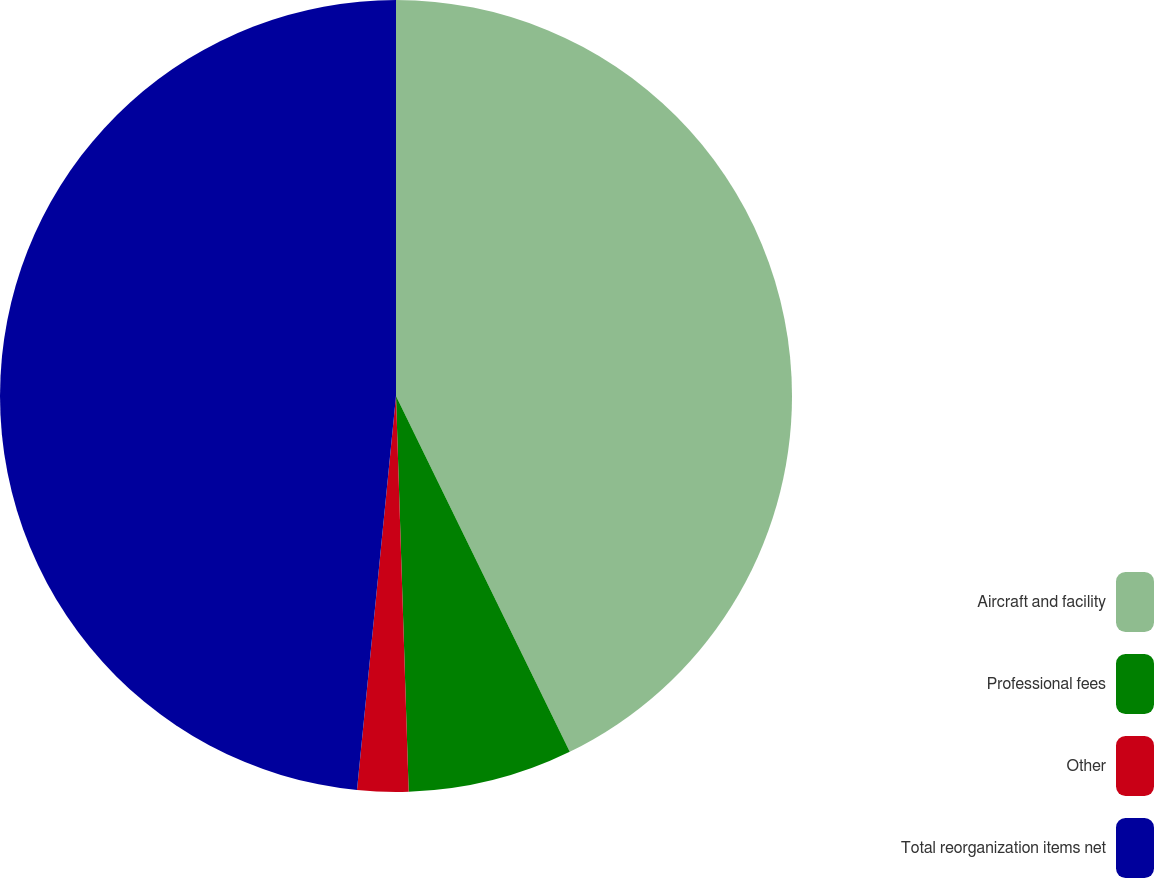Convert chart to OTSL. <chart><loc_0><loc_0><loc_500><loc_500><pie_chart><fcel>Aircraft and facility<fcel>Professional fees<fcel>Other<fcel>Total reorganization items net<nl><fcel>42.77%<fcel>6.72%<fcel>2.08%<fcel>48.43%<nl></chart> 